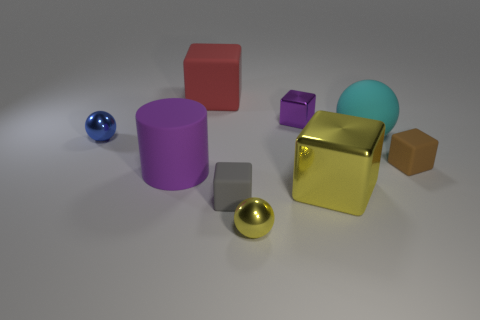Subtract all gray cubes. How many cubes are left? 4 Subtract 1 balls. How many balls are left? 2 Subtract all purple blocks. How many blocks are left? 4 Add 1 big purple matte objects. How many objects exist? 10 Subtract all spheres. How many objects are left? 6 Subtract all brown balls. Subtract all gray blocks. How many balls are left? 3 Add 5 tiny metallic balls. How many tiny metallic balls are left? 7 Add 3 small green metallic cubes. How many small green metallic cubes exist? 3 Subtract 0 cyan blocks. How many objects are left? 9 Subtract all brown matte things. Subtract all small things. How many objects are left? 3 